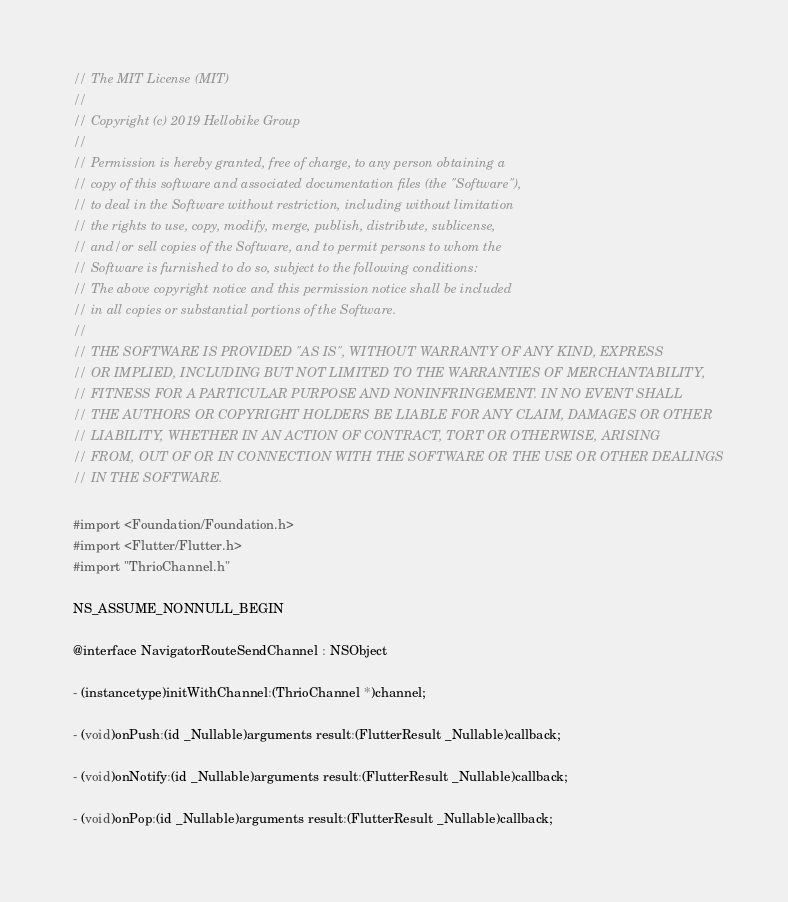<code> <loc_0><loc_0><loc_500><loc_500><_C_>// The MIT License (MIT)
//
// Copyright (c) 2019 Hellobike Group
//
// Permission is hereby granted, free of charge, to any person obtaining a
// copy of this software and associated documentation files (the "Software"),
// to deal in the Software without restriction, including without limitation
// the rights to use, copy, modify, merge, publish, distribute, sublicense,
// and/or sell copies of the Software, and to permit persons to whom the
// Software is furnished to do so, subject to the following conditions:
// The above copyright notice and this permission notice shall be included
// in all copies or substantial portions of the Software.
//
// THE SOFTWARE IS PROVIDED "AS IS", WITHOUT WARRANTY OF ANY KIND, EXPRESS
// OR IMPLIED, INCLUDING BUT NOT LIMITED TO THE WARRANTIES OF MERCHANTABILITY,
// FITNESS FOR A PARTICULAR PURPOSE AND NONINFRINGEMENT. IN NO EVENT SHALL
// THE AUTHORS OR COPYRIGHT HOLDERS BE LIABLE FOR ANY CLAIM, DAMAGES OR OTHER
// LIABILITY, WHETHER IN AN ACTION OF CONTRACT, TORT OR OTHERWISE, ARISING
// FROM, OUT OF OR IN CONNECTION WITH THE SOFTWARE OR THE USE OR OTHER DEALINGS
// IN THE SOFTWARE.

#import <Foundation/Foundation.h>
#import <Flutter/Flutter.h>
#import "ThrioChannel.h"

NS_ASSUME_NONNULL_BEGIN

@interface NavigatorRouteSendChannel : NSObject

- (instancetype)initWithChannel:(ThrioChannel *)channel;

- (void)onPush:(id _Nullable)arguments result:(FlutterResult _Nullable)callback;

- (void)onNotify:(id _Nullable)arguments result:(FlutterResult _Nullable)callback;

- (void)onPop:(id _Nullable)arguments result:(FlutterResult _Nullable)callback;
</code> 